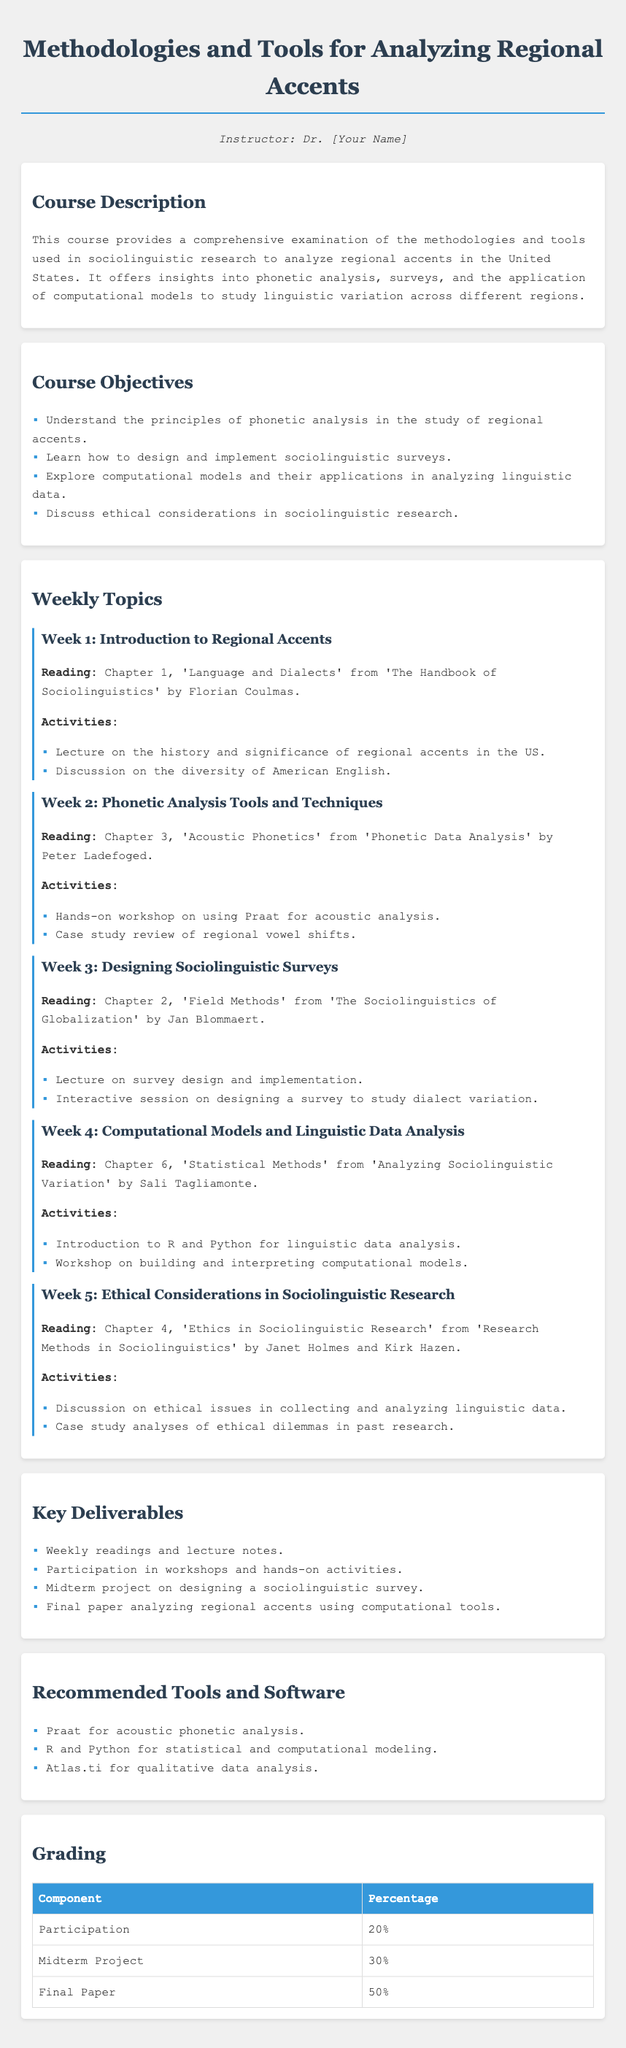What is the course title? The course title is mentioned prominently at the top of the document as "Methodologies and Tools for Analyzing Regional Accents."
Answer: Methodologies and Tools for Analyzing Regional Accents Who is the instructor? The instructor's name is typically placed in the section designed for instructor information. Here, it is marked as "Dr. [Your Name]."
Answer: Dr. [Your Name] What percentage of the grade is based on the final paper? The grading section provides a breakdown of percentages for different components, stating that the final paper contributes 50% of the overall grade.
Answer: 50% Which software is recommended for acoustic phonetic analysis? The recommended tools and software section lists specific tools for various analyses, mentioning "Praat" for acoustic phonetic analysis.
Answer: Praat What is the focus of Week 2? Week 2's title and content indicate a focus on "Phonetic Analysis Tools and Techniques," along with a reading from "Phonetic Data Analysis."
Answer: Phonetic Analysis Tools and Techniques In which week do students learn about ethical considerations in sociolinguistic research? The weekly topics section outlines the content for each week, with Week 5 dedicated to discussing ethical considerations in research.
Answer: Week 5 What type of activity is included in Week 3? The activities for Week 3 include an "interactive session on designing a survey to study dialect variation," which suggests a hands-on approach.
Answer: Interactive session on designing a survey What is covered in the reading for Week 4? The reading for Week 4 is mentioned as Chapter 6, 'Statistical Methods' from 'Analyzing Sociolinguistic Variation' by Sali Tagliamonte, indicating a focus on statistical methods.
Answer: Chapter 6, 'Statistical Methods' from 'Analyzing Sociolinguistic Variation' What is the first reading assigned in Week 1? The first reading is denoted for Week 1, which is Chapter 1, 'Language and Dialects' from 'The Handbook of Sociolinguistics' by Florian Coulmas.
Answer: Chapter 1, 'Language and Dialects' from 'The Handbook of Sociolinguistics' 